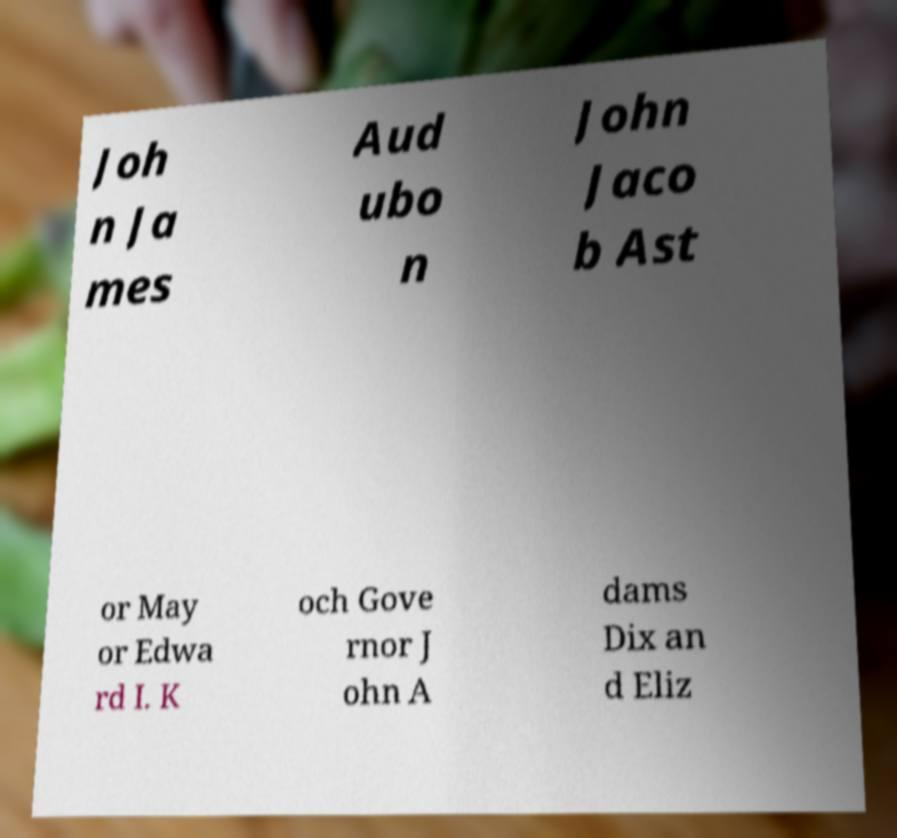I need the written content from this picture converted into text. Can you do that? Joh n Ja mes Aud ubo n John Jaco b Ast or May or Edwa rd I. K och Gove rnor J ohn A dams Dix an d Eliz 